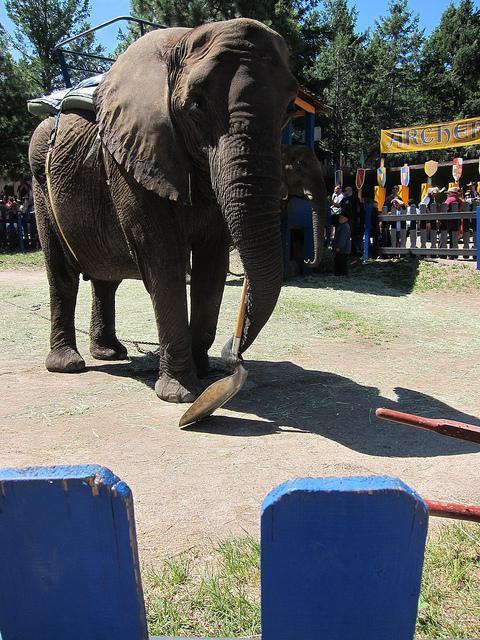How many elephants can you see?
Give a very brief answer. 2. 